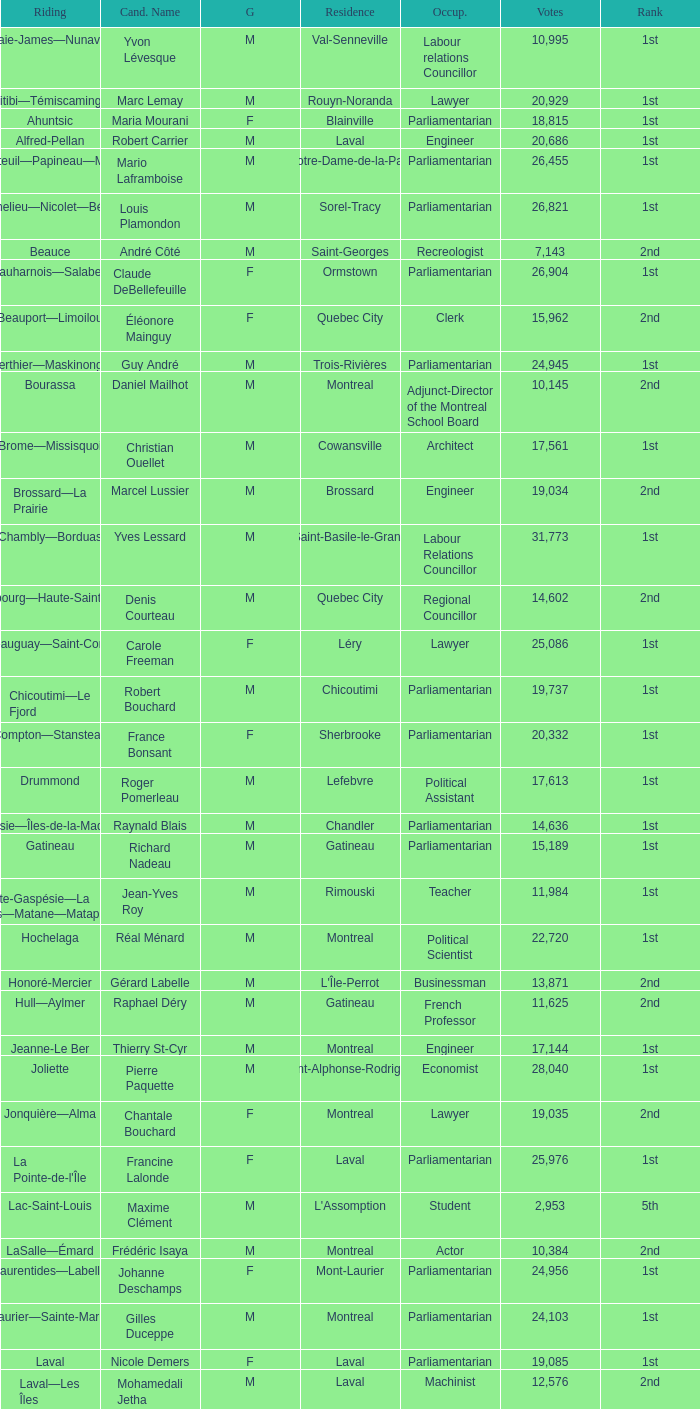What gender is Luc Desnoyers? M. 